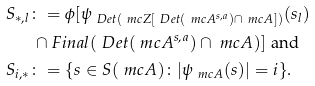<formula> <loc_0><loc_0><loc_500><loc_500>S _ { * , l } & \colon = \phi [ \psi _ { \ D e t ( \ m c { Z } [ \ D e t ( \ m c { A } ^ { s , a } ) \cap \ m c { A } ] ) } ( s _ { l } ) \\ & \, \cap F i n a l ( \ D e t ( \ m c { A } ^ { s , a } ) \cap \ m c { A } ) ] \text {\ and} \\ S _ { i , * } & \colon = \{ s \in S ( \ m c { A } ) \colon | \psi _ { \ m c { A } } ( s ) | = i \} .</formula> 